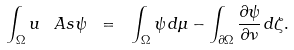Convert formula to latex. <formula><loc_0><loc_0><loc_500><loc_500>\int _ { \Omega } u \, \ A s \psi \ = \ \int _ { \Omega } \psi \, d \mu - \int _ { \partial \Omega } \frac { \partial \psi } { \partial \nu } \, d \zeta .</formula> 